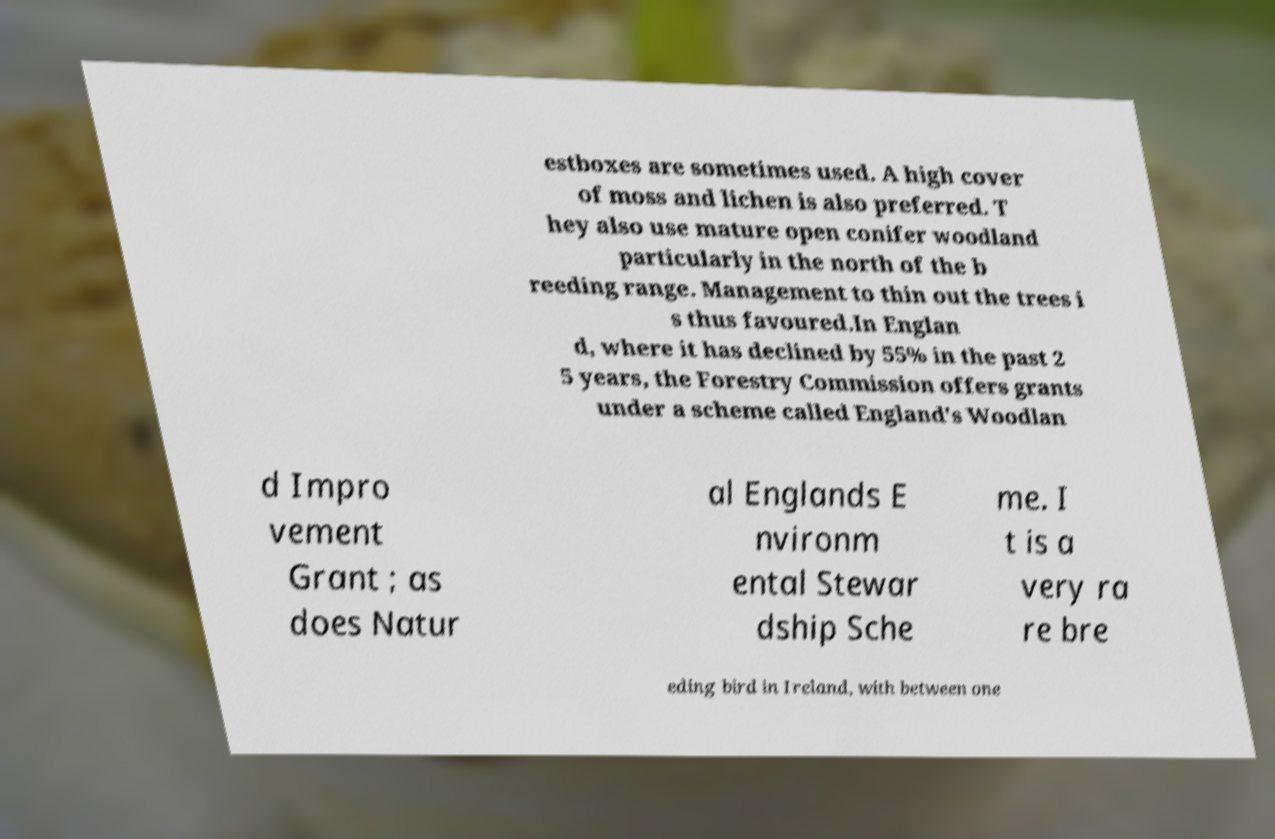Could you extract and type out the text from this image? estboxes are sometimes used. A high cover of moss and lichen is also preferred. T hey also use mature open conifer woodland particularly in the north of the b reeding range. Management to thin out the trees i s thus favoured.In Englan d, where it has declined by 55% in the past 2 5 years, the Forestry Commission offers grants under a scheme called England's Woodlan d Impro vement Grant ; as does Natur al Englands E nvironm ental Stewar dship Sche me. I t is a very ra re bre eding bird in Ireland, with between one 